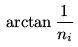<formula> <loc_0><loc_0><loc_500><loc_500>\arctan { \frac { 1 } { n _ { i } } }</formula> 